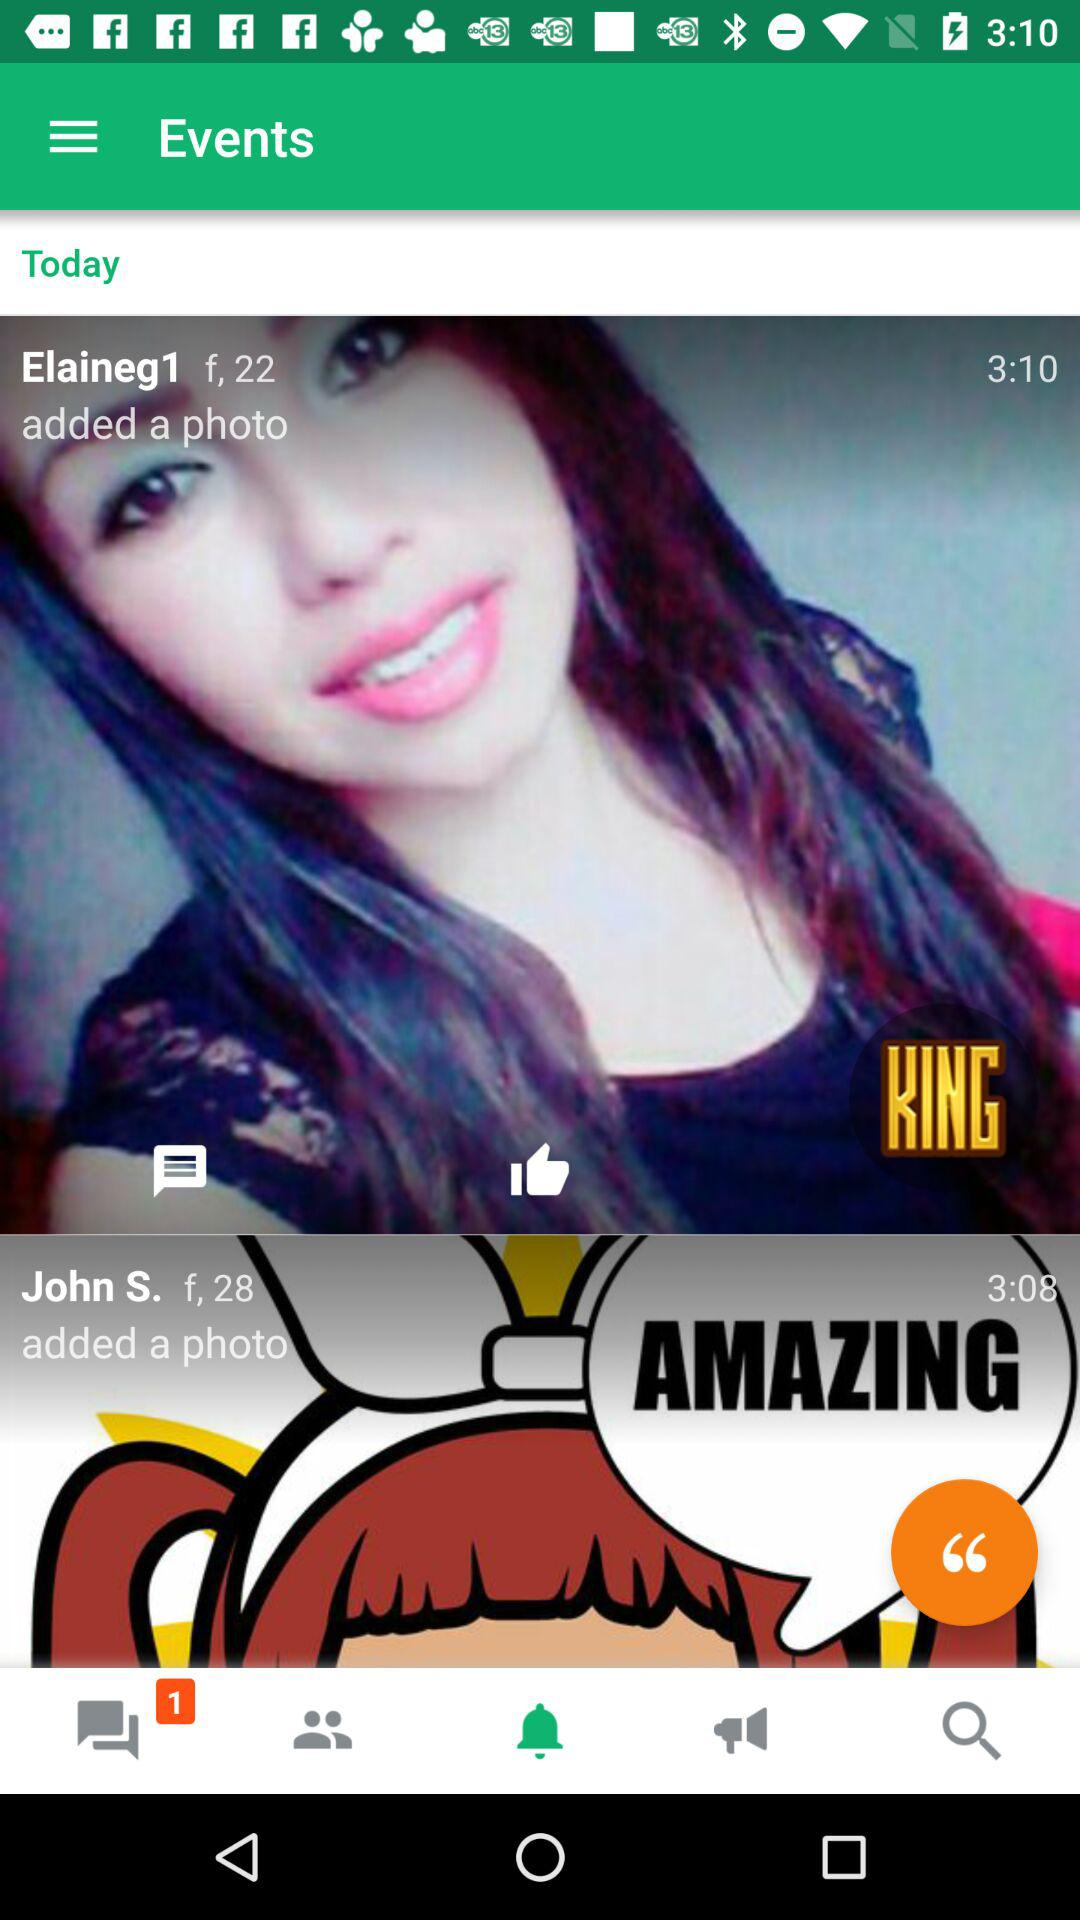What is the age of John S.? John S. is 28 years old. 